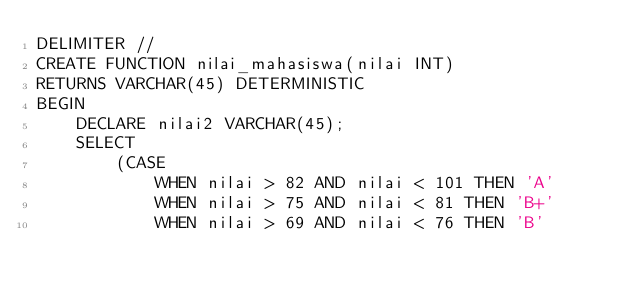Convert code to text. <code><loc_0><loc_0><loc_500><loc_500><_SQL_>DELIMITER //
CREATE FUNCTION nilai_mahasiswa(nilai INT)
RETURNS VARCHAR(45) DETERMINISTIC
BEGIN
    DECLARE nilai2 VARCHAR(45);
    SELECT 
        (CASE
            WHEN nilai > 82 AND nilai < 101 THEN 'A'
            WHEN nilai > 75 AND nilai < 81 THEN 'B+'
            WHEN nilai > 69 AND nilai < 76 THEN 'B'</code> 